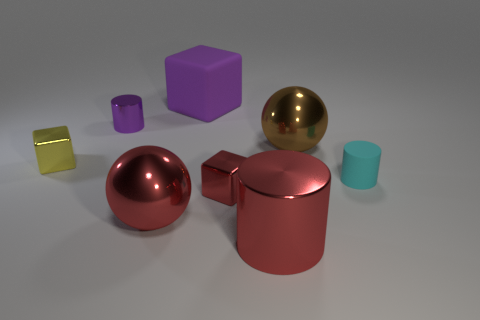Subtract all metallic cubes. How many cubes are left? 1 Subtract 1 cylinders. How many cylinders are left? 2 Add 1 small cylinders. How many objects exist? 9 Subtract all cylinders. How many objects are left? 5 Subtract all blue cubes. Subtract all gray spheres. How many cubes are left? 3 Add 3 brown things. How many brown things exist? 4 Subtract 0 yellow balls. How many objects are left? 8 Subtract all red balls. Subtract all small metallic things. How many objects are left? 4 Add 1 large purple cubes. How many large purple cubes are left? 2 